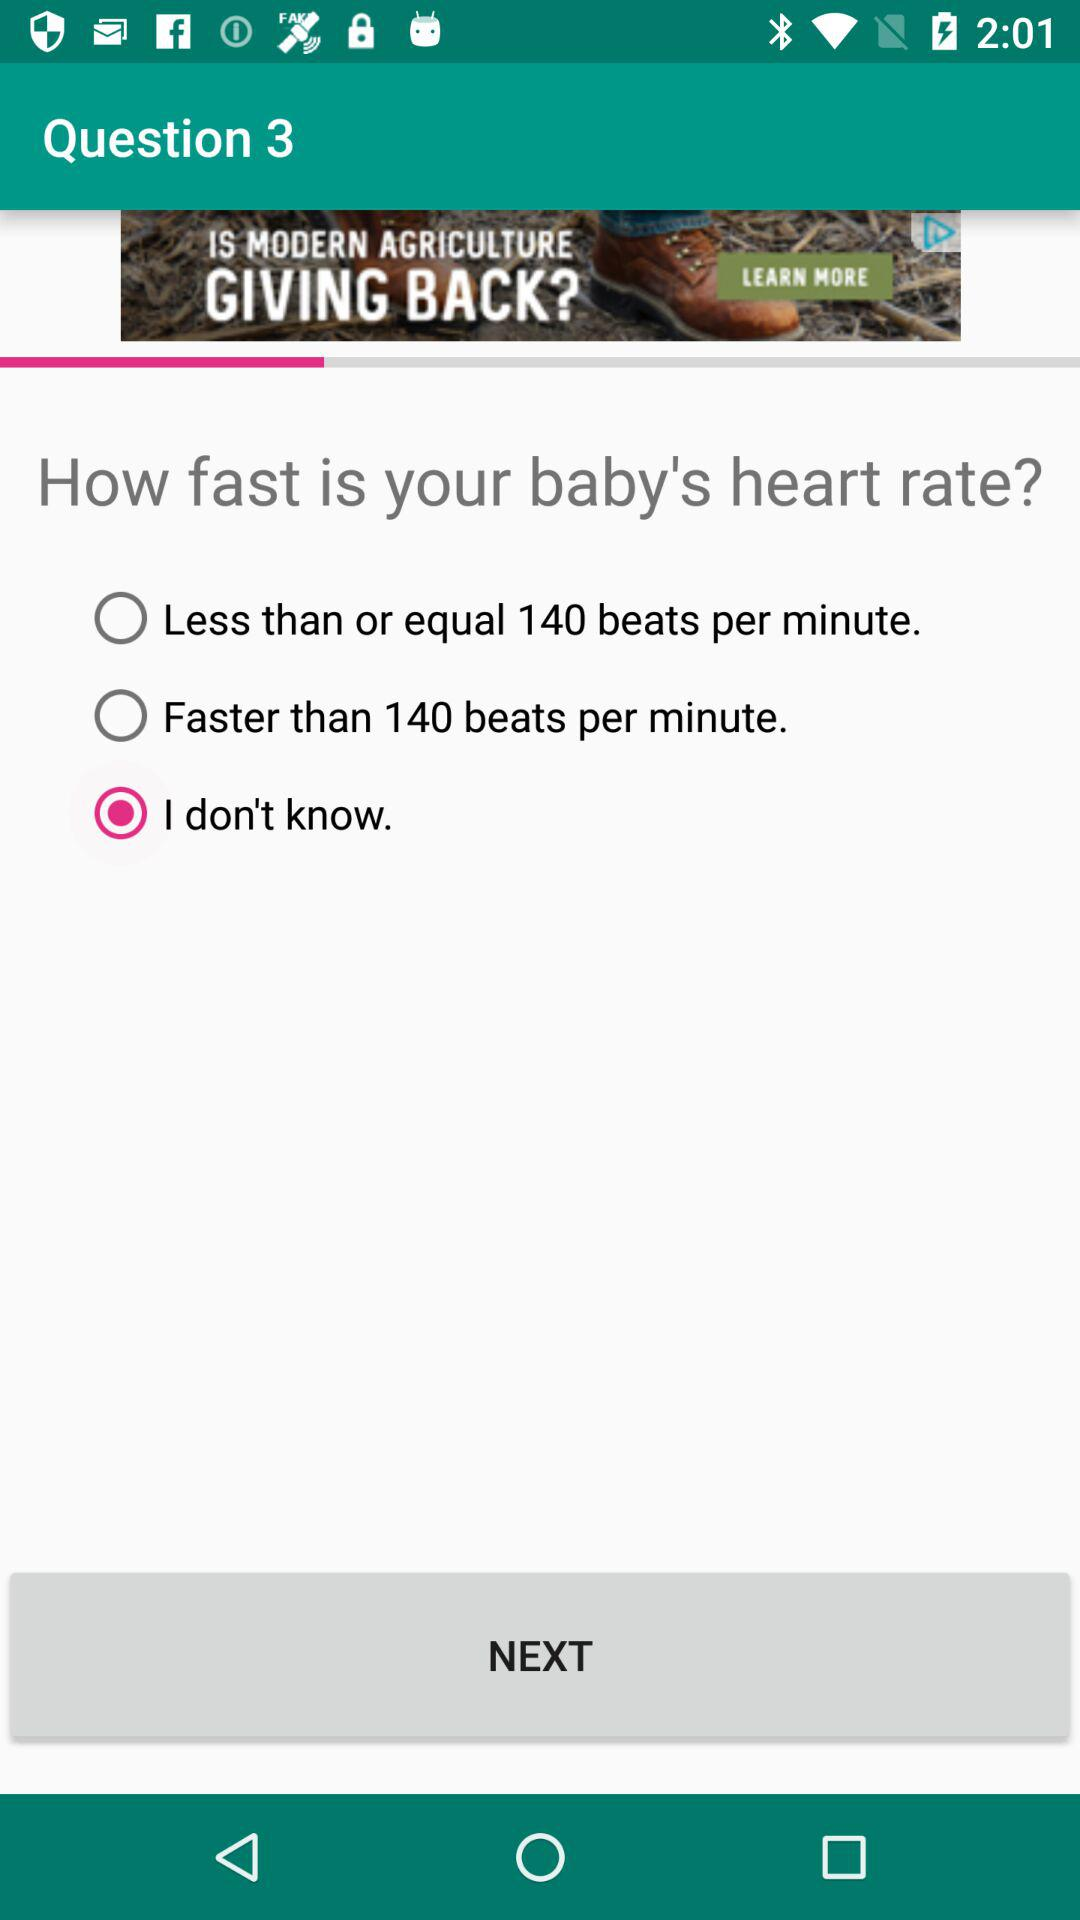What is the question number? Question number is 3. 